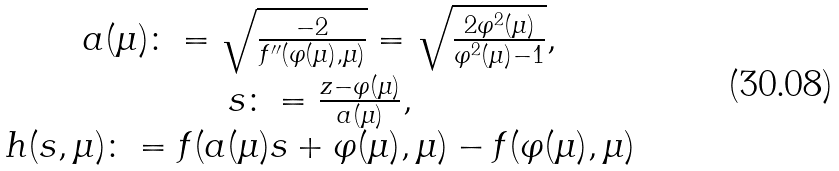<formula> <loc_0><loc_0><loc_500><loc_500>\begin{array} { c } a ( \mu ) \colon = \sqrt { \frac { - 2 } { f ^ { \prime \prime } ( \varphi ( \mu ) , \mu ) } } = \sqrt { \frac { 2 \varphi ^ { 2 } ( \mu ) } { \varphi ^ { 2 } ( \mu ) - 1 } } , \\ s \colon = \frac { z - \varphi ( \mu ) } { a ( \mu ) } , \\ h ( s , \mu ) \colon = f ( a ( \mu ) s + \varphi ( \mu ) , \mu ) - f ( \varphi ( \mu ) , \mu ) \end{array}</formula> 